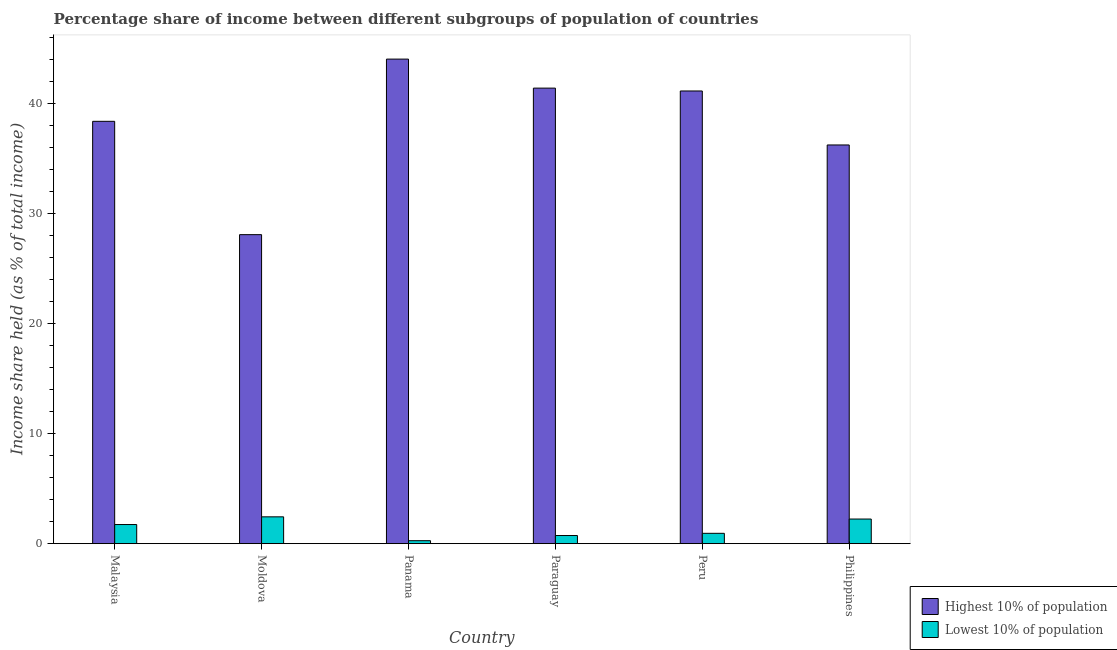How many different coloured bars are there?
Ensure brevity in your answer.  2. Are the number of bars on each tick of the X-axis equal?
Keep it short and to the point. Yes. How many bars are there on the 5th tick from the left?
Provide a succinct answer. 2. What is the label of the 1st group of bars from the left?
Offer a very short reply. Malaysia. What is the income share held by highest 10% of the population in Peru?
Provide a short and direct response. 41.18. Across all countries, what is the maximum income share held by lowest 10% of the population?
Offer a very short reply. 2.44. Across all countries, what is the minimum income share held by highest 10% of the population?
Your answer should be very brief. 28.11. In which country was the income share held by lowest 10% of the population maximum?
Provide a succinct answer. Moldova. In which country was the income share held by highest 10% of the population minimum?
Ensure brevity in your answer.  Moldova. What is the total income share held by highest 10% of the population in the graph?
Your response must be concise. 229.5. What is the difference between the income share held by lowest 10% of the population in Paraguay and that in Philippines?
Your answer should be very brief. -1.5. What is the difference between the income share held by lowest 10% of the population in Philippines and the income share held by highest 10% of the population in Panama?
Offer a very short reply. -41.84. What is the average income share held by lowest 10% of the population per country?
Your answer should be very brief. 1.39. What is the difference between the income share held by lowest 10% of the population and income share held by highest 10% of the population in Panama?
Offer a very short reply. -43.81. In how many countries, is the income share held by lowest 10% of the population greater than 2 %?
Your answer should be very brief. 2. What is the ratio of the income share held by lowest 10% of the population in Panama to that in Paraguay?
Your answer should be compact. 0.36. Is the income share held by lowest 10% of the population in Panama less than that in Peru?
Make the answer very short. Yes. Is the difference between the income share held by highest 10% of the population in Moldova and Philippines greater than the difference between the income share held by lowest 10% of the population in Moldova and Philippines?
Ensure brevity in your answer.  No. What is the difference between the highest and the second highest income share held by lowest 10% of the population?
Offer a terse response. 0.2. What is the difference between the highest and the lowest income share held by highest 10% of the population?
Give a very brief answer. 15.97. In how many countries, is the income share held by highest 10% of the population greater than the average income share held by highest 10% of the population taken over all countries?
Provide a succinct answer. 4. Is the sum of the income share held by highest 10% of the population in Peru and Philippines greater than the maximum income share held by lowest 10% of the population across all countries?
Provide a succinct answer. Yes. What does the 1st bar from the left in Paraguay represents?
Offer a very short reply. Highest 10% of population. What does the 2nd bar from the right in Malaysia represents?
Ensure brevity in your answer.  Highest 10% of population. How many bars are there?
Your answer should be compact. 12. How many countries are there in the graph?
Make the answer very short. 6. What is the difference between two consecutive major ticks on the Y-axis?
Offer a terse response. 10. Are the values on the major ticks of Y-axis written in scientific E-notation?
Provide a short and direct response. No. Does the graph contain any zero values?
Provide a succinct answer. No. Does the graph contain grids?
Provide a short and direct response. No. How many legend labels are there?
Offer a terse response. 2. How are the legend labels stacked?
Keep it short and to the point. Vertical. What is the title of the graph?
Keep it short and to the point. Percentage share of income between different subgroups of population of countries. Does "current US$" appear as one of the legend labels in the graph?
Your response must be concise. No. What is the label or title of the Y-axis?
Your answer should be compact. Income share held (as % of total income). What is the Income share held (as % of total income) in Highest 10% of population in Malaysia?
Offer a very short reply. 38.42. What is the Income share held (as % of total income) of Lowest 10% of population in Malaysia?
Your answer should be very brief. 1.74. What is the Income share held (as % of total income) in Highest 10% of population in Moldova?
Ensure brevity in your answer.  28.11. What is the Income share held (as % of total income) of Lowest 10% of population in Moldova?
Your answer should be very brief. 2.44. What is the Income share held (as % of total income) in Highest 10% of population in Panama?
Provide a succinct answer. 44.08. What is the Income share held (as % of total income) in Lowest 10% of population in Panama?
Your answer should be very brief. 0.27. What is the Income share held (as % of total income) of Highest 10% of population in Paraguay?
Keep it short and to the point. 41.44. What is the Income share held (as % of total income) of Lowest 10% of population in Paraguay?
Your response must be concise. 0.74. What is the Income share held (as % of total income) of Highest 10% of population in Peru?
Your answer should be very brief. 41.18. What is the Income share held (as % of total income) of Lowest 10% of population in Peru?
Provide a short and direct response. 0.94. What is the Income share held (as % of total income) of Highest 10% of population in Philippines?
Your response must be concise. 36.27. What is the Income share held (as % of total income) of Lowest 10% of population in Philippines?
Ensure brevity in your answer.  2.24. Across all countries, what is the maximum Income share held (as % of total income) in Highest 10% of population?
Provide a succinct answer. 44.08. Across all countries, what is the maximum Income share held (as % of total income) of Lowest 10% of population?
Give a very brief answer. 2.44. Across all countries, what is the minimum Income share held (as % of total income) of Highest 10% of population?
Ensure brevity in your answer.  28.11. Across all countries, what is the minimum Income share held (as % of total income) in Lowest 10% of population?
Offer a very short reply. 0.27. What is the total Income share held (as % of total income) of Highest 10% of population in the graph?
Your answer should be compact. 229.5. What is the total Income share held (as % of total income) in Lowest 10% of population in the graph?
Provide a short and direct response. 8.37. What is the difference between the Income share held (as % of total income) in Highest 10% of population in Malaysia and that in Moldova?
Offer a very short reply. 10.31. What is the difference between the Income share held (as % of total income) of Highest 10% of population in Malaysia and that in Panama?
Make the answer very short. -5.66. What is the difference between the Income share held (as % of total income) in Lowest 10% of population in Malaysia and that in Panama?
Your answer should be very brief. 1.47. What is the difference between the Income share held (as % of total income) in Highest 10% of population in Malaysia and that in Paraguay?
Provide a short and direct response. -3.02. What is the difference between the Income share held (as % of total income) of Lowest 10% of population in Malaysia and that in Paraguay?
Provide a short and direct response. 1. What is the difference between the Income share held (as % of total income) in Highest 10% of population in Malaysia and that in Peru?
Make the answer very short. -2.76. What is the difference between the Income share held (as % of total income) in Lowest 10% of population in Malaysia and that in Peru?
Give a very brief answer. 0.8. What is the difference between the Income share held (as % of total income) in Highest 10% of population in Malaysia and that in Philippines?
Offer a very short reply. 2.15. What is the difference between the Income share held (as % of total income) in Lowest 10% of population in Malaysia and that in Philippines?
Provide a short and direct response. -0.5. What is the difference between the Income share held (as % of total income) in Highest 10% of population in Moldova and that in Panama?
Provide a succinct answer. -15.97. What is the difference between the Income share held (as % of total income) of Lowest 10% of population in Moldova and that in Panama?
Offer a terse response. 2.17. What is the difference between the Income share held (as % of total income) of Highest 10% of population in Moldova and that in Paraguay?
Make the answer very short. -13.33. What is the difference between the Income share held (as % of total income) in Highest 10% of population in Moldova and that in Peru?
Your answer should be very brief. -13.07. What is the difference between the Income share held (as % of total income) of Lowest 10% of population in Moldova and that in Peru?
Your answer should be very brief. 1.5. What is the difference between the Income share held (as % of total income) in Highest 10% of population in Moldova and that in Philippines?
Ensure brevity in your answer.  -8.16. What is the difference between the Income share held (as % of total income) in Highest 10% of population in Panama and that in Paraguay?
Give a very brief answer. 2.64. What is the difference between the Income share held (as % of total income) in Lowest 10% of population in Panama and that in Paraguay?
Your answer should be very brief. -0.47. What is the difference between the Income share held (as % of total income) of Lowest 10% of population in Panama and that in Peru?
Offer a terse response. -0.67. What is the difference between the Income share held (as % of total income) in Highest 10% of population in Panama and that in Philippines?
Provide a short and direct response. 7.81. What is the difference between the Income share held (as % of total income) in Lowest 10% of population in Panama and that in Philippines?
Your answer should be very brief. -1.97. What is the difference between the Income share held (as % of total income) in Highest 10% of population in Paraguay and that in Peru?
Provide a succinct answer. 0.26. What is the difference between the Income share held (as % of total income) of Highest 10% of population in Paraguay and that in Philippines?
Make the answer very short. 5.17. What is the difference between the Income share held (as % of total income) of Highest 10% of population in Peru and that in Philippines?
Provide a succinct answer. 4.91. What is the difference between the Income share held (as % of total income) in Highest 10% of population in Malaysia and the Income share held (as % of total income) in Lowest 10% of population in Moldova?
Your response must be concise. 35.98. What is the difference between the Income share held (as % of total income) in Highest 10% of population in Malaysia and the Income share held (as % of total income) in Lowest 10% of population in Panama?
Make the answer very short. 38.15. What is the difference between the Income share held (as % of total income) of Highest 10% of population in Malaysia and the Income share held (as % of total income) of Lowest 10% of population in Paraguay?
Offer a very short reply. 37.68. What is the difference between the Income share held (as % of total income) in Highest 10% of population in Malaysia and the Income share held (as % of total income) in Lowest 10% of population in Peru?
Provide a short and direct response. 37.48. What is the difference between the Income share held (as % of total income) of Highest 10% of population in Malaysia and the Income share held (as % of total income) of Lowest 10% of population in Philippines?
Your response must be concise. 36.18. What is the difference between the Income share held (as % of total income) in Highest 10% of population in Moldova and the Income share held (as % of total income) in Lowest 10% of population in Panama?
Ensure brevity in your answer.  27.84. What is the difference between the Income share held (as % of total income) in Highest 10% of population in Moldova and the Income share held (as % of total income) in Lowest 10% of population in Paraguay?
Your answer should be very brief. 27.37. What is the difference between the Income share held (as % of total income) of Highest 10% of population in Moldova and the Income share held (as % of total income) of Lowest 10% of population in Peru?
Offer a terse response. 27.17. What is the difference between the Income share held (as % of total income) of Highest 10% of population in Moldova and the Income share held (as % of total income) of Lowest 10% of population in Philippines?
Offer a very short reply. 25.87. What is the difference between the Income share held (as % of total income) of Highest 10% of population in Panama and the Income share held (as % of total income) of Lowest 10% of population in Paraguay?
Your response must be concise. 43.34. What is the difference between the Income share held (as % of total income) in Highest 10% of population in Panama and the Income share held (as % of total income) in Lowest 10% of population in Peru?
Your answer should be compact. 43.14. What is the difference between the Income share held (as % of total income) of Highest 10% of population in Panama and the Income share held (as % of total income) of Lowest 10% of population in Philippines?
Provide a succinct answer. 41.84. What is the difference between the Income share held (as % of total income) in Highest 10% of population in Paraguay and the Income share held (as % of total income) in Lowest 10% of population in Peru?
Offer a very short reply. 40.5. What is the difference between the Income share held (as % of total income) in Highest 10% of population in Paraguay and the Income share held (as % of total income) in Lowest 10% of population in Philippines?
Provide a succinct answer. 39.2. What is the difference between the Income share held (as % of total income) in Highest 10% of population in Peru and the Income share held (as % of total income) in Lowest 10% of population in Philippines?
Give a very brief answer. 38.94. What is the average Income share held (as % of total income) of Highest 10% of population per country?
Make the answer very short. 38.25. What is the average Income share held (as % of total income) of Lowest 10% of population per country?
Offer a very short reply. 1.4. What is the difference between the Income share held (as % of total income) of Highest 10% of population and Income share held (as % of total income) of Lowest 10% of population in Malaysia?
Your response must be concise. 36.68. What is the difference between the Income share held (as % of total income) in Highest 10% of population and Income share held (as % of total income) in Lowest 10% of population in Moldova?
Provide a short and direct response. 25.67. What is the difference between the Income share held (as % of total income) of Highest 10% of population and Income share held (as % of total income) of Lowest 10% of population in Panama?
Give a very brief answer. 43.81. What is the difference between the Income share held (as % of total income) in Highest 10% of population and Income share held (as % of total income) in Lowest 10% of population in Paraguay?
Your answer should be very brief. 40.7. What is the difference between the Income share held (as % of total income) of Highest 10% of population and Income share held (as % of total income) of Lowest 10% of population in Peru?
Your answer should be compact. 40.24. What is the difference between the Income share held (as % of total income) in Highest 10% of population and Income share held (as % of total income) in Lowest 10% of population in Philippines?
Offer a very short reply. 34.03. What is the ratio of the Income share held (as % of total income) in Highest 10% of population in Malaysia to that in Moldova?
Keep it short and to the point. 1.37. What is the ratio of the Income share held (as % of total income) of Lowest 10% of population in Malaysia to that in Moldova?
Ensure brevity in your answer.  0.71. What is the ratio of the Income share held (as % of total income) of Highest 10% of population in Malaysia to that in Panama?
Provide a short and direct response. 0.87. What is the ratio of the Income share held (as % of total income) of Lowest 10% of population in Malaysia to that in Panama?
Offer a very short reply. 6.44. What is the ratio of the Income share held (as % of total income) in Highest 10% of population in Malaysia to that in Paraguay?
Keep it short and to the point. 0.93. What is the ratio of the Income share held (as % of total income) of Lowest 10% of population in Malaysia to that in Paraguay?
Give a very brief answer. 2.35. What is the ratio of the Income share held (as % of total income) of Highest 10% of population in Malaysia to that in Peru?
Your response must be concise. 0.93. What is the ratio of the Income share held (as % of total income) of Lowest 10% of population in Malaysia to that in Peru?
Make the answer very short. 1.85. What is the ratio of the Income share held (as % of total income) in Highest 10% of population in Malaysia to that in Philippines?
Provide a short and direct response. 1.06. What is the ratio of the Income share held (as % of total income) of Lowest 10% of population in Malaysia to that in Philippines?
Your response must be concise. 0.78. What is the ratio of the Income share held (as % of total income) in Highest 10% of population in Moldova to that in Panama?
Your answer should be compact. 0.64. What is the ratio of the Income share held (as % of total income) in Lowest 10% of population in Moldova to that in Panama?
Provide a succinct answer. 9.04. What is the ratio of the Income share held (as % of total income) in Highest 10% of population in Moldova to that in Paraguay?
Make the answer very short. 0.68. What is the ratio of the Income share held (as % of total income) in Lowest 10% of population in Moldova to that in Paraguay?
Provide a short and direct response. 3.3. What is the ratio of the Income share held (as % of total income) in Highest 10% of population in Moldova to that in Peru?
Your answer should be compact. 0.68. What is the ratio of the Income share held (as % of total income) of Lowest 10% of population in Moldova to that in Peru?
Make the answer very short. 2.6. What is the ratio of the Income share held (as % of total income) of Highest 10% of population in Moldova to that in Philippines?
Keep it short and to the point. 0.78. What is the ratio of the Income share held (as % of total income) of Lowest 10% of population in Moldova to that in Philippines?
Your answer should be very brief. 1.09. What is the ratio of the Income share held (as % of total income) of Highest 10% of population in Panama to that in Paraguay?
Your answer should be very brief. 1.06. What is the ratio of the Income share held (as % of total income) in Lowest 10% of population in Panama to that in Paraguay?
Offer a terse response. 0.36. What is the ratio of the Income share held (as % of total income) of Highest 10% of population in Panama to that in Peru?
Provide a short and direct response. 1.07. What is the ratio of the Income share held (as % of total income) in Lowest 10% of population in Panama to that in Peru?
Keep it short and to the point. 0.29. What is the ratio of the Income share held (as % of total income) of Highest 10% of population in Panama to that in Philippines?
Your response must be concise. 1.22. What is the ratio of the Income share held (as % of total income) of Lowest 10% of population in Panama to that in Philippines?
Offer a very short reply. 0.12. What is the ratio of the Income share held (as % of total income) in Lowest 10% of population in Paraguay to that in Peru?
Provide a short and direct response. 0.79. What is the ratio of the Income share held (as % of total income) in Highest 10% of population in Paraguay to that in Philippines?
Provide a short and direct response. 1.14. What is the ratio of the Income share held (as % of total income) in Lowest 10% of population in Paraguay to that in Philippines?
Keep it short and to the point. 0.33. What is the ratio of the Income share held (as % of total income) of Highest 10% of population in Peru to that in Philippines?
Your answer should be compact. 1.14. What is the ratio of the Income share held (as % of total income) in Lowest 10% of population in Peru to that in Philippines?
Your answer should be very brief. 0.42. What is the difference between the highest and the second highest Income share held (as % of total income) of Highest 10% of population?
Your answer should be very brief. 2.64. What is the difference between the highest and the lowest Income share held (as % of total income) of Highest 10% of population?
Provide a succinct answer. 15.97. What is the difference between the highest and the lowest Income share held (as % of total income) of Lowest 10% of population?
Ensure brevity in your answer.  2.17. 